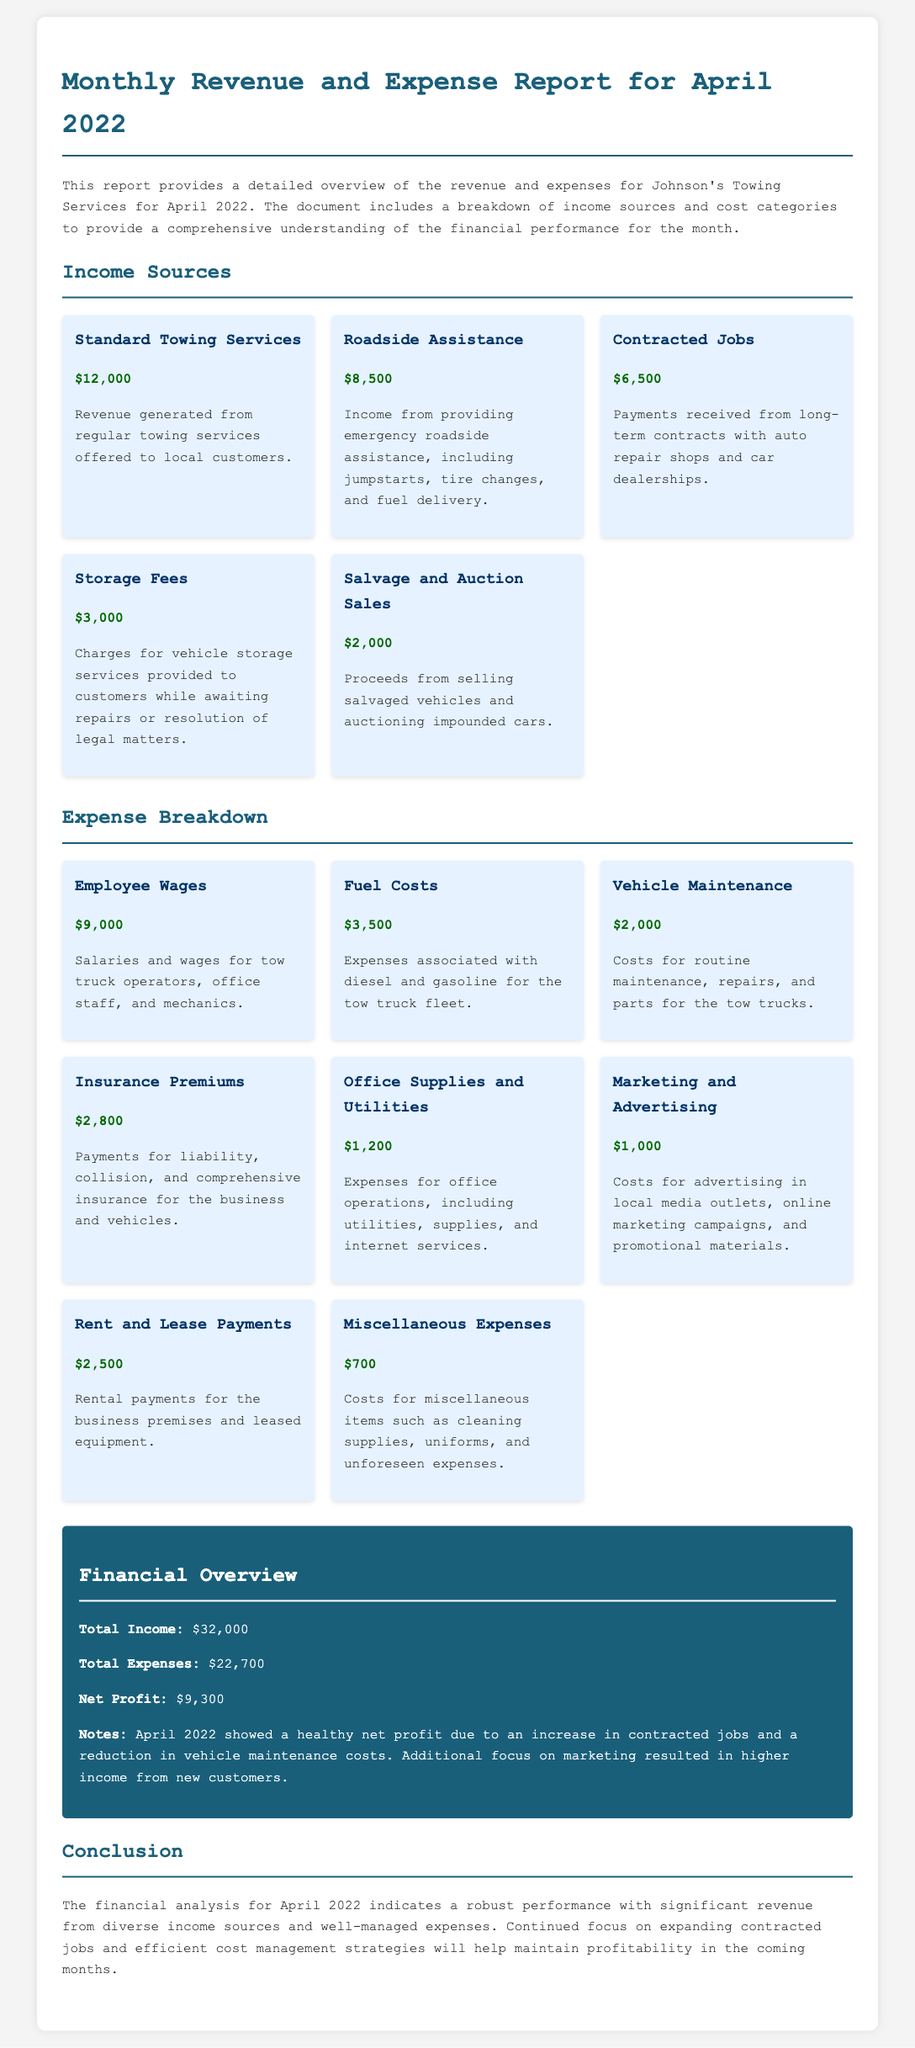What is the total income? The total income is clearly stated as $32,000 in the financial overview section of the document.
Answer: $32,000 What are the total expenses? The total expenses are mentioned in the financial overview section, specifically listed as $22,700.
Answer: $22,700 What is the net profit? The net profit can be found in the financial overview section and is noted as $9,300.
Answer: $9,300 Which income source generated the highest revenue? The document indicates that the income source with the highest revenue is Standard Towing Services, amounting to $12,000.
Answer: Standard Towing Services What are employee wages? Employee wages are listed under expenses in the document and account for $9,000.
Answer: $9,000 What is the cost of fuel? The document provides the cost of fuel as part of the expense breakdown, specifying $3,500.
Answer: $3,500 Which category had the lowest income? Salvage and Auction Sales generated the lowest income, amounting to $2,000, as shown in the income sources section.
Answer: Salvage and Auction Sales How much was spent on marketing and advertising? The document includes the amount spent on marketing and advertising as $1,000 under expense breakdown.
Answer: $1,000 What is noted as a contributing factor to the net profit in April 2022? The notes in the financial overview mention an increase in contracted jobs as a contributing factor to the net profit.
Answer: Increase in contracted jobs What did the conclusion suggest focusing on for maintaining profitability? The conclusion suggests a continued focus on expanding contracted jobs and efficient cost management strategies for profitability.
Answer: Expanding contracted jobs and efficient cost management strategies 